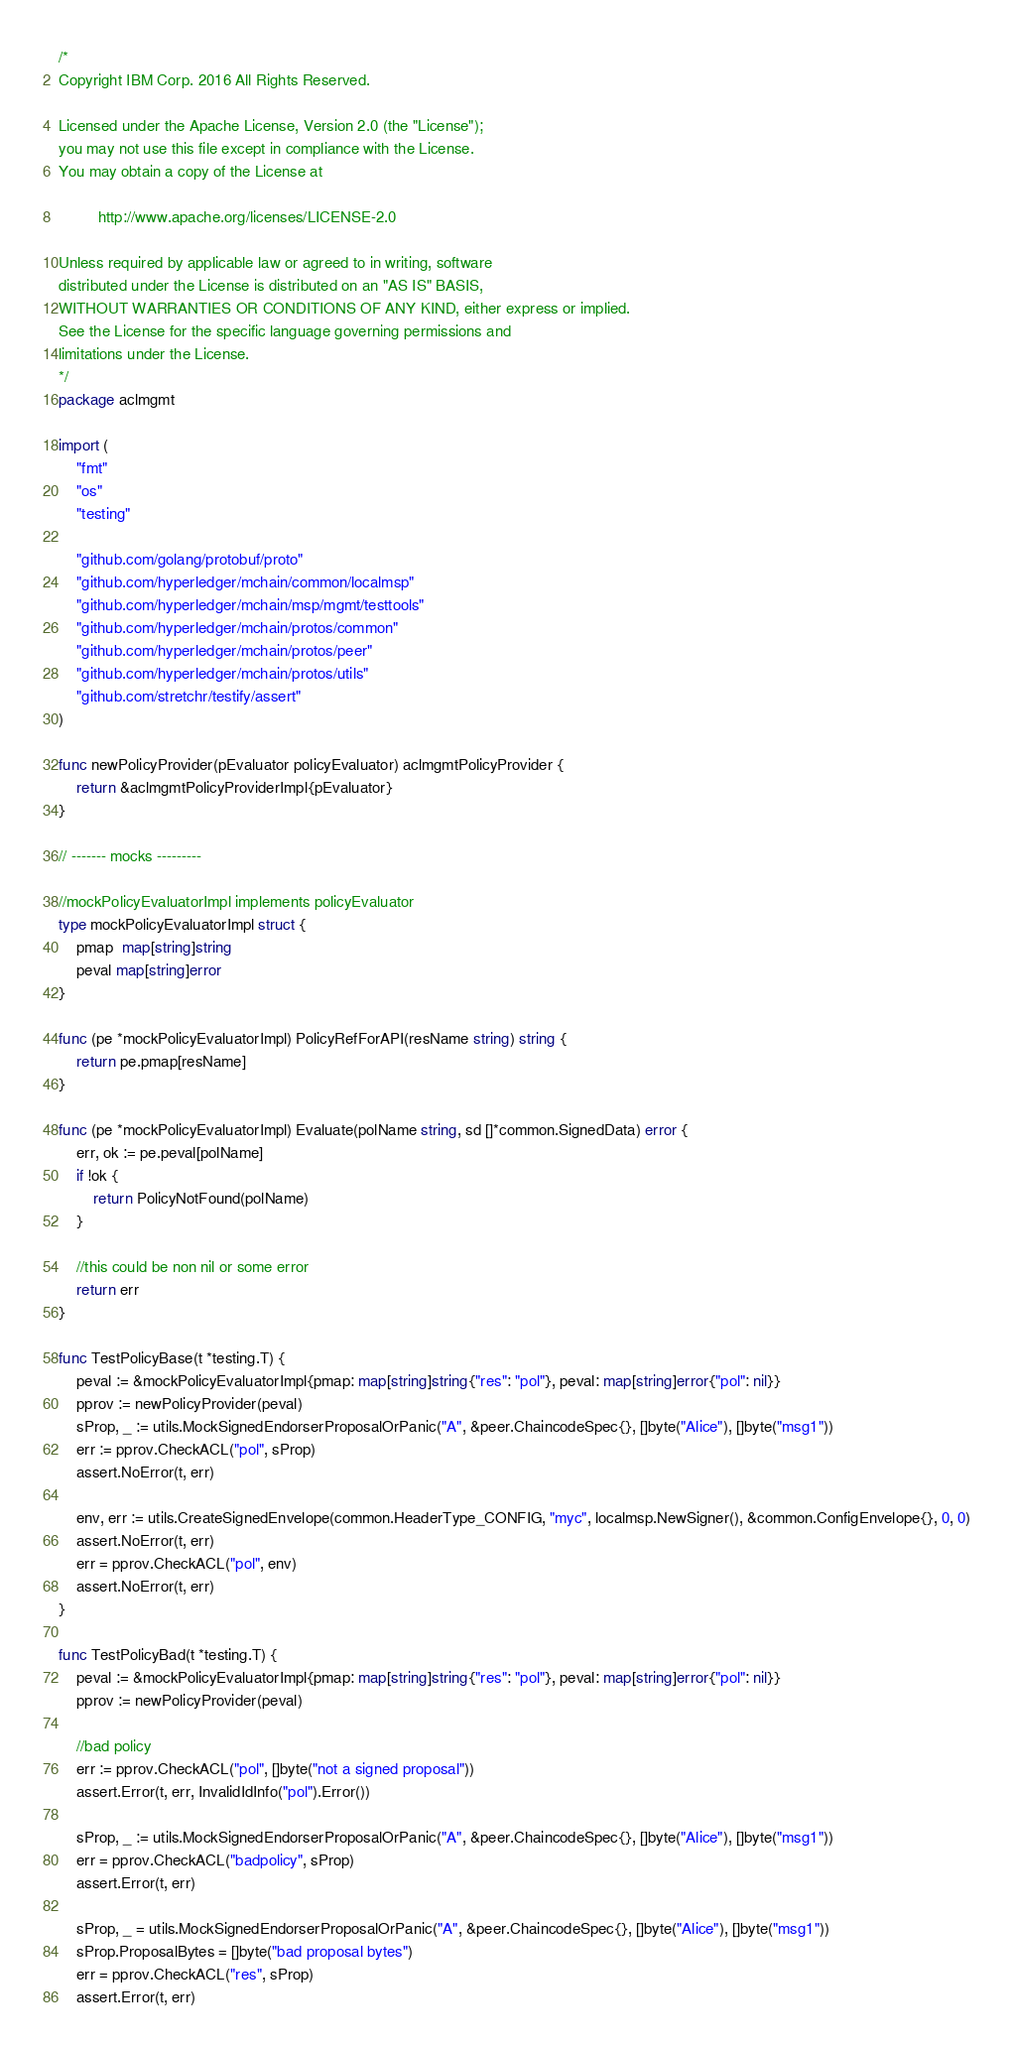<code> <loc_0><loc_0><loc_500><loc_500><_Go_>/*
Copyright IBM Corp. 2016 All Rights Reserved.

Licensed under the Apache License, Version 2.0 (the "License");
you may not use this file except in compliance with the License.
You may obtain a copy of the License at

		 http://www.apache.org/licenses/LICENSE-2.0

Unless required by applicable law or agreed to in writing, software
distributed under the License is distributed on an "AS IS" BASIS,
WITHOUT WARRANTIES OR CONDITIONS OF ANY KIND, either express or implied.
See the License for the specific language governing permissions and
limitations under the License.
*/
package aclmgmt

import (
	"fmt"
	"os"
	"testing"

	"github.com/golang/protobuf/proto"
	"github.com/hyperledger/mchain/common/localmsp"
	"github.com/hyperledger/mchain/msp/mgmt/testtools"
	"github.com/hyperledger/mchain/protos/common"
	"github.com/hyperledger/mchain/protos/peer"
	"github.com/hyperledger/mchain/protos/utils"
	"github.com/stretchr/testify/assert"
)

func newPolicyProvider(pEvaluator policyEvaluator) aclmgmtPolicyProvider {
	return &aclmgmtPolicyProviderImpl{pEvaluator}
}

// ------- mocks ---------

//mockPolicyEvaluatorImpl implements policyEvaluator
type mockPolicyEvaluatorImpl struct {
	pmap  map[string]string
	peval map[string]error
}

func (pe *mockPolicyEvaluatorImpl) PolicyRefForAPI(resName string) string {
	return pe.pmap[resName]
}

func (pe *mockPolicyEvaluatorImpl) Evaluate(polName string, sd []*common.SignedData) error {
	err, ok := pe.peval[polName]
	if !ok {
		return PolicyNotFound(polName)
	}

	//this could be non nil or some error
	return err
}

func TestPolicyBase(t *testing.T) {
	peval := &mockPolicyEvaluatorImpl{pmap: map[string]string{"res": "pol"}, peval: map[string]error{"pol": nil}}
	pprov := newPolicyProvider(peval)
	sProp, _ := utils.MockSignedEndorserProposalOrPanic("A", &peer.ChaincodeSpec{}, []byte("Alice"), []byte("msg1"))
	err := pprov.CheckACL("pol", sProp)
	assert.NoError(t, err)

	env, err := utils.CreateSignedEnvelope(common.HeaderType_CONFIG, "myc", localmsp.NewSigner(), &common.ConfigEnvelope{}, 0, 0)
	assert.NoError(t, err)
	err = pprov.CheckACL("pol", env)
	assert.NoError(t, err)
}

func TestPolicyBad(t *testing.T) {
	peval := &mockPolicyEvaluatorImpl{pmap: map[string]string{"res": "pol"}, peval: map[string]error{"pol": nil}}
	pprov := newPolicyProvider(peval)

	//bad policy
	err := pprov.CheckACL("pol", []byte("not a signed proposal"))
	assert.Error(t, err, InvalidIdInfo("pol").Error())

	sProp, _ := utils.MockSignedEndorserProposalOrPanic("A", &peer.ChaincodeSpec{}, []byte("Alice"), []byte("msg1"))
	err = pprov.CheckACL("badpolicy", sProp)
	assert.Error(t, err)

	sProp, _ = utils.MockSignedEndorserProposalOrPanic("A", &peer.ChaincodeSpec{}, []byte("Alice"), []byte("msg1"))
	sProp.ProposalBytes = []byte("bad proposal bytes")
	err = pprov.CheckACL("res", sProp)
	assert.Error(t, err)
</code> 